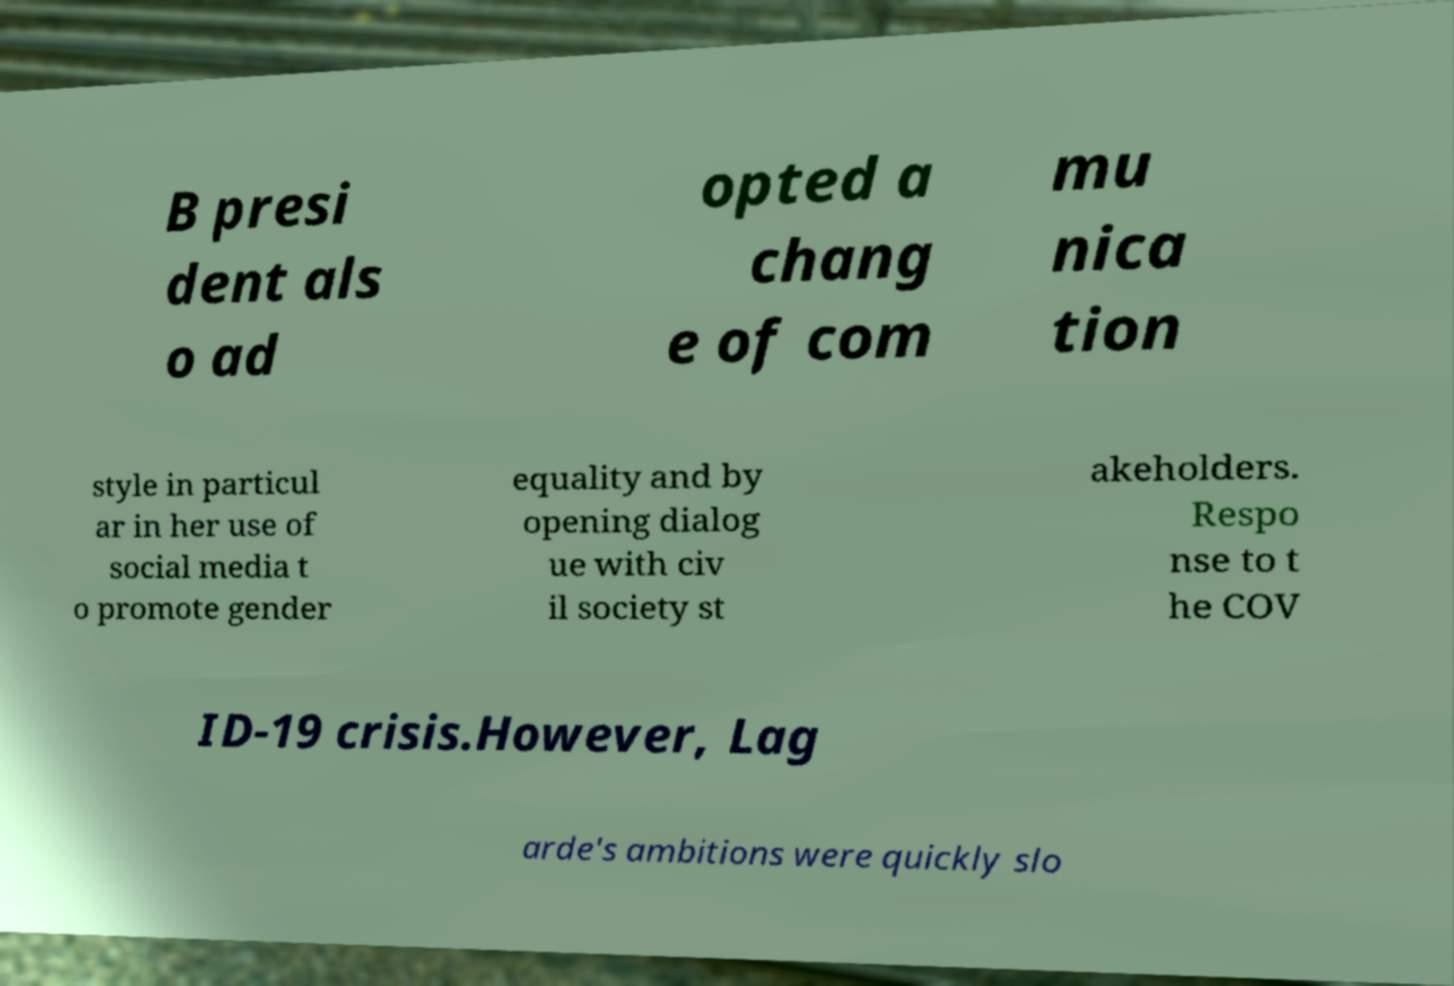Please identify and transcribe the text found in this image. B presi dent als o ad opted a chang e of com mu nica tion style in particul ar in her use of social media t o promote gender equality and by opening dialog ue with civ il society st akeholders. Respo nse to t he COV ID-19 crisis.However, Lag arde's ambitions were quickly slo 